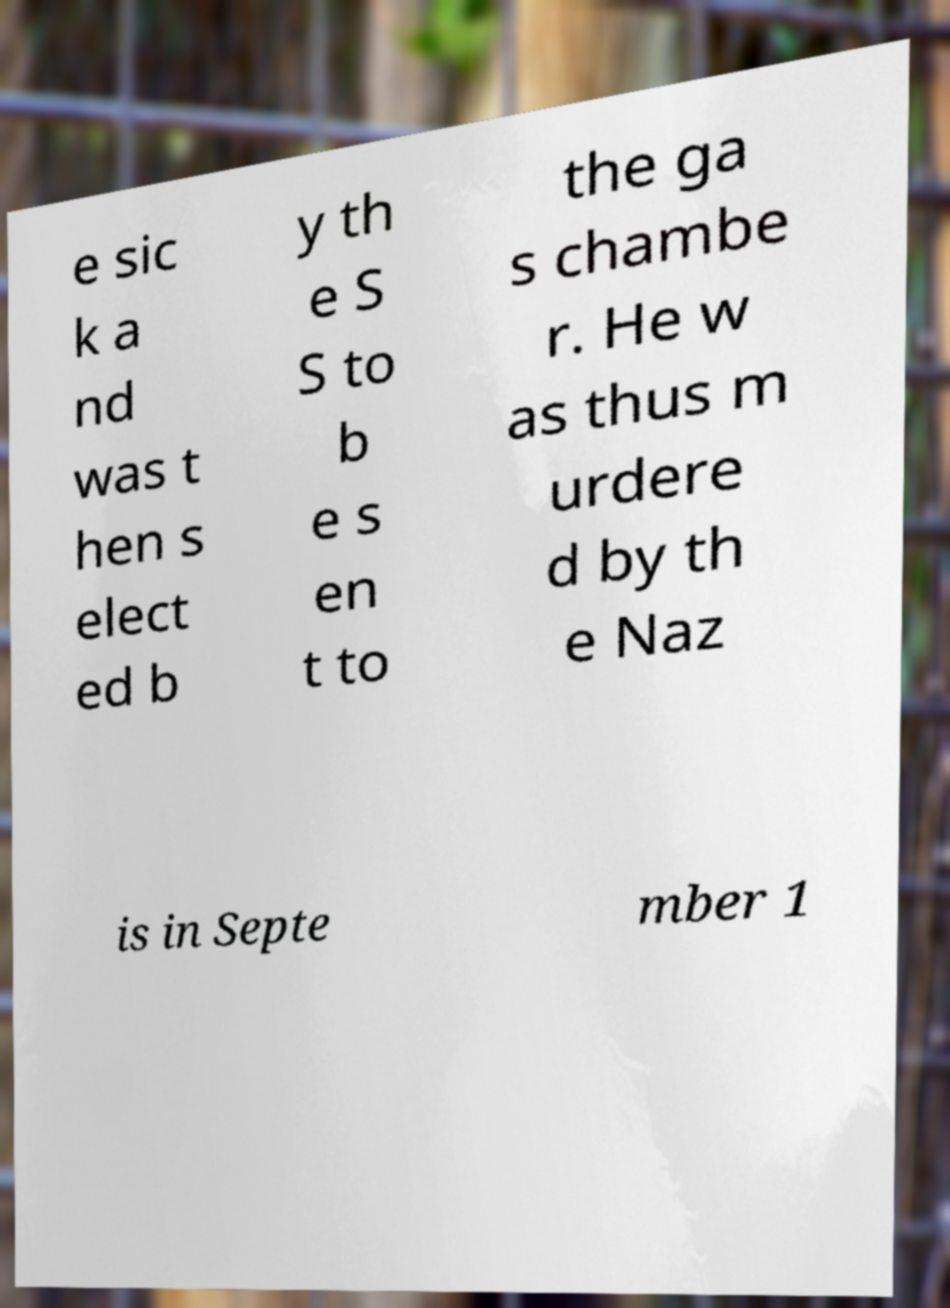Could you extract and type out the text from this image? e sic k a nd was t hen s elect ed b y th e S S to b e s en t to the ga s chambe r. He w as thus m urdere d by th e Naz is in Septe mber 1 